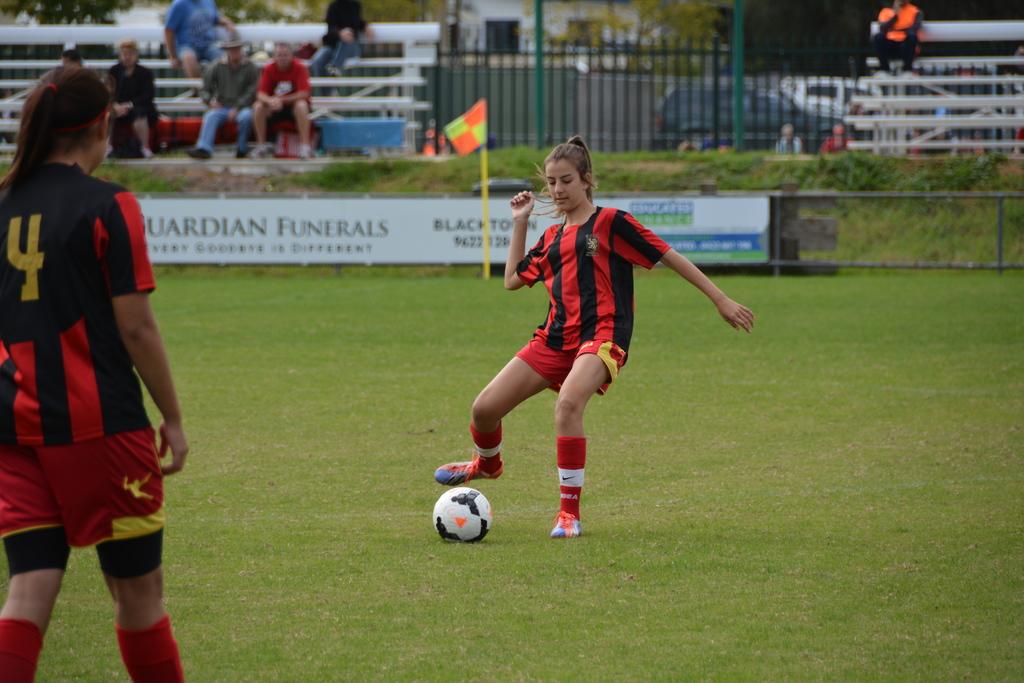What is the jersey number of the girl in front?
Your response must be concise. 4. What type of service is being advertised on the white banner?
Give a very brief answer. Funerals. 